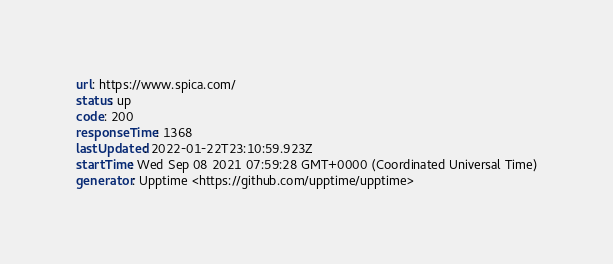Convert code to text. <code><loc_0><loc_0><loc_500><loc_500><_YAML_>url: https://www.spica.com/
status: up
code: 200
responseTime: 1368
lastUpdated: 2022-01-22T23:10:59.923Z
startTime: Wed Sep 08 2021 07:59:28 GMT+0000 (Coordinated Universal Time)
generator: Upptime <https://github.com/upptime/upptime>
</code> 